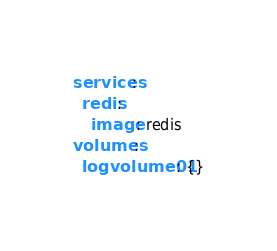<code> <loc_0><loc_0><loc_500><loc_500><_YAML_>services:
  redis:
    image: redis
volumes:
  logvolume01: {}
</code> 